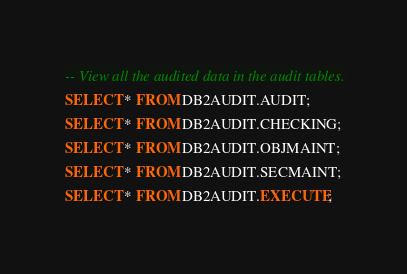<code> <loc_0><loc_0><loc_500><loc_500><_SQL_>-- View all the audited data in the audit tables.
SELECT * FROM DB2AUDIT.AUDIT;
SELECT * FROM DB2AUDIT.CHECKING;
SELECT * FROM DB2AUDIT.OBJMAINT;
SELECT * FROM DB2AUDIT.SECMAINT;
SELECT * FROM DB2AUDIT.EXECUTE;</code> 